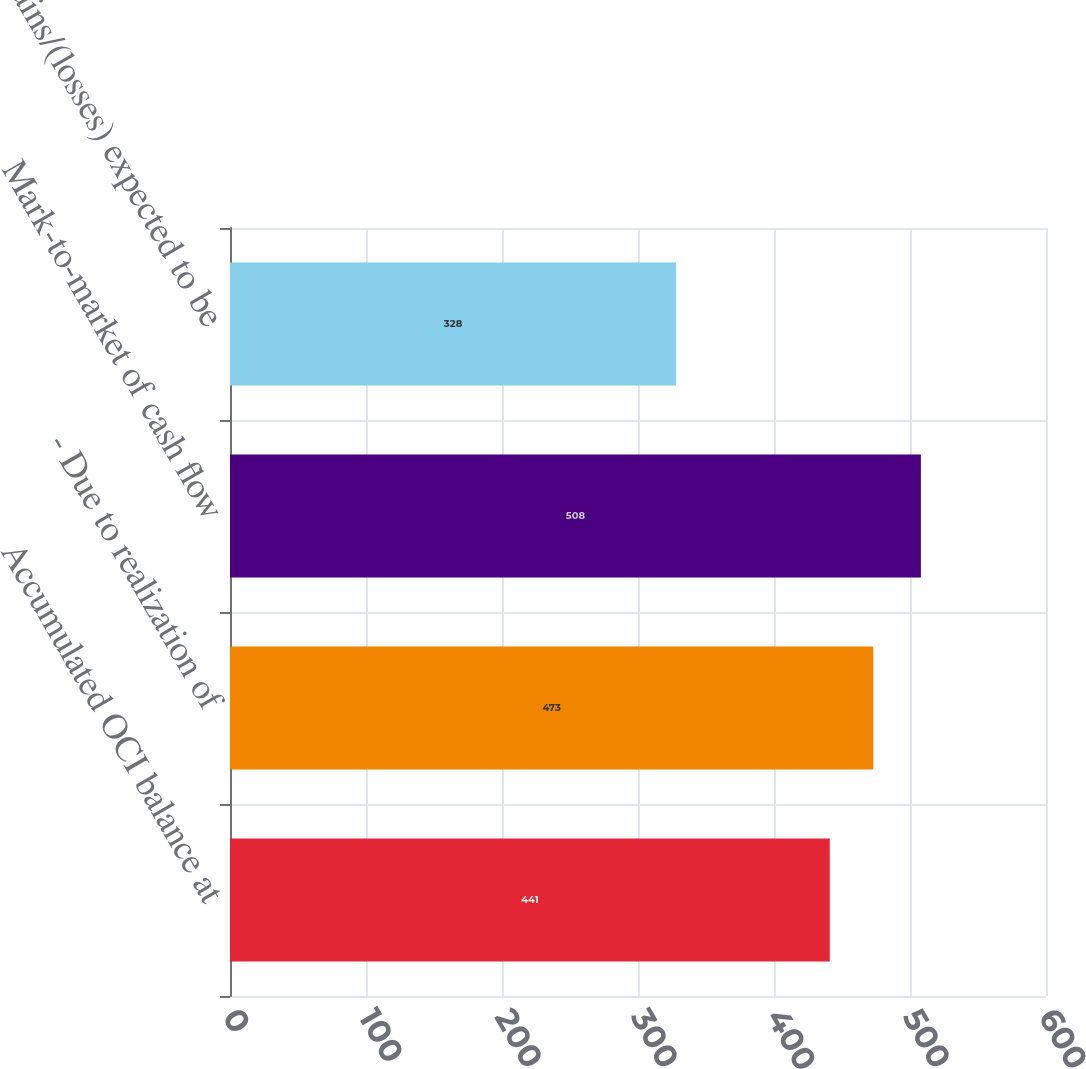Convert chart to OTSL. <chart><loc_0><loc_0><loc_500><loc_500><bar_chart><fcel>Accumulated OCI balance at<fcel>- Due to realization of<fcel>Mark-to-market of cash flow<fcel>Gains/(losses) expected to be<nl><fcel>441<fcel>473<fcel>508<fcel>328<nl></chart> 